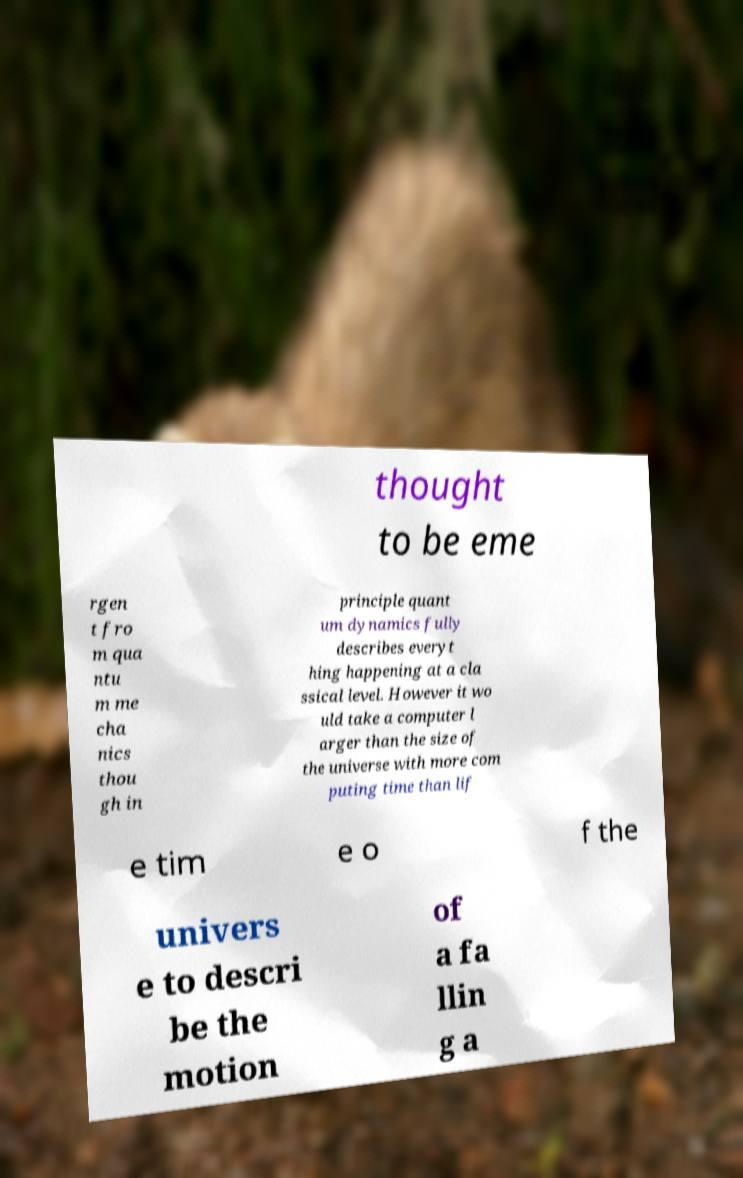Please read and relay the text visible in this image. What does it say? thought to be eme rgen t fro m qua ntu m me cha nics thou gh in principle quant um dynamics fully describes everyt hing happening at a cla ssical level. However it wo uld take a computer l arger than the size of the universe with more com puting time than lif e tim e o f the univers e to descri be the motion of a fa llin g a 